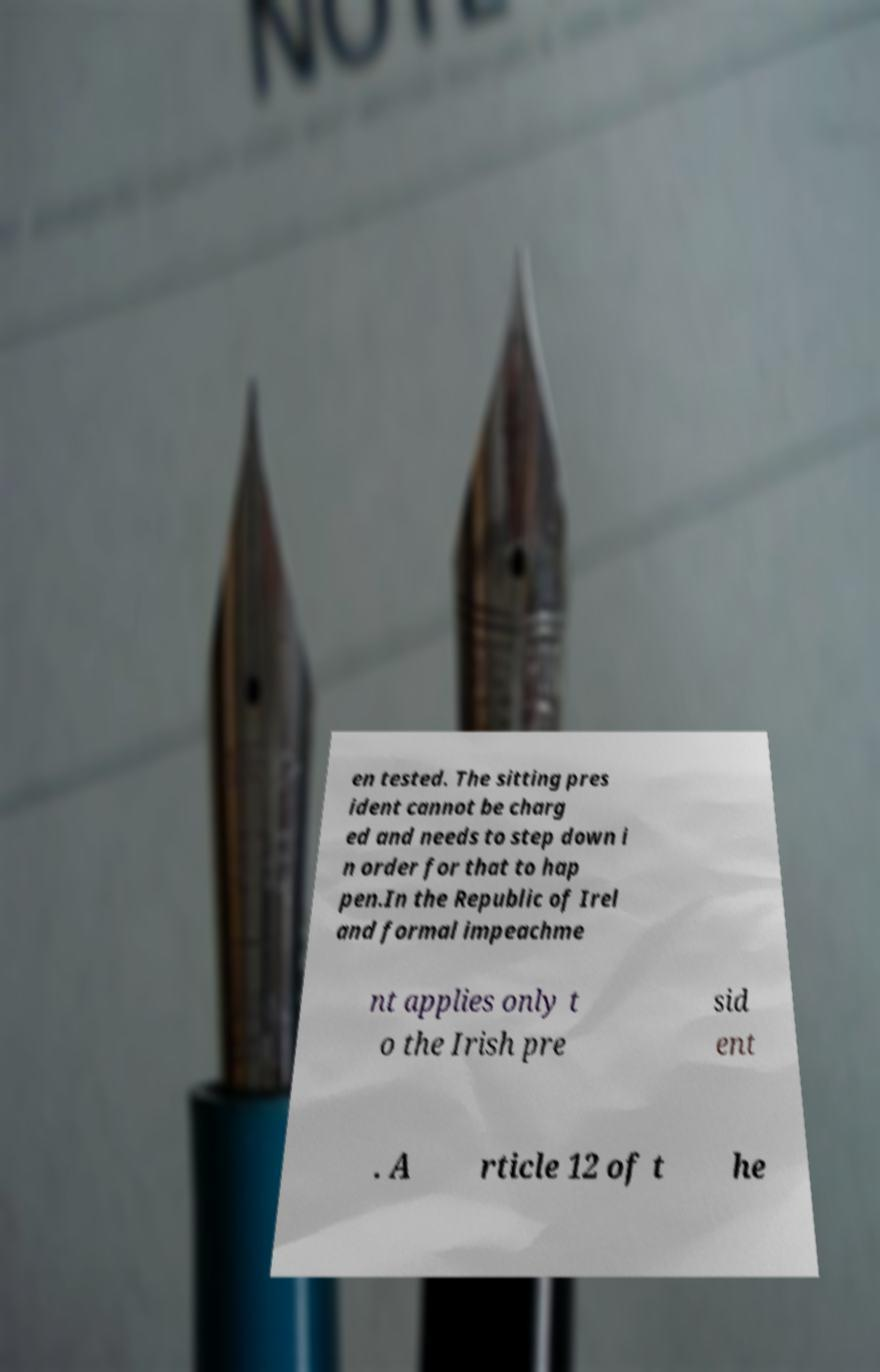There's text embedded in this image that I need extracted. Can you transcribe it verbatim? en tested. The sitting pres ident cannot be charg ed and needs to step down i n order for that to hap pen.In the Republic of Irel and formal impeachme nt applies only t o the Irish pre sid ent . A rticle 12 of t he 